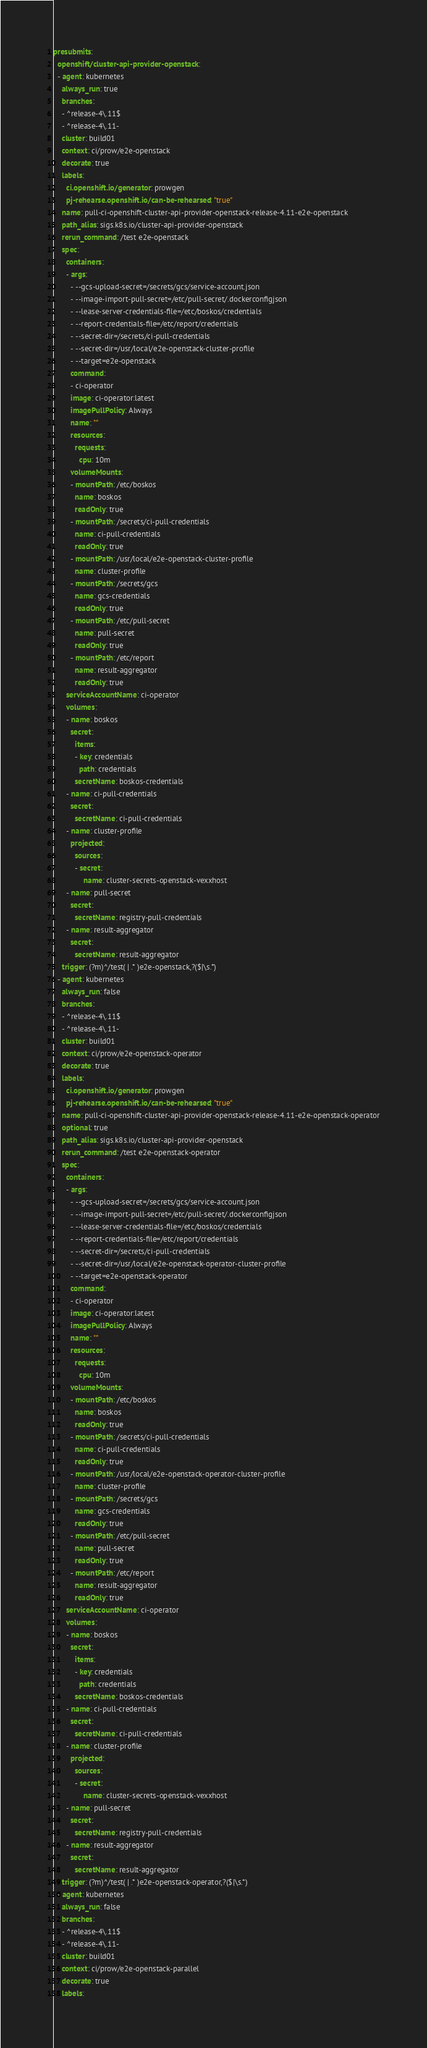Convert code to text. <code><loc_0><loc_0><loc_500><loc_500><_YAML_>presubmits:
  openshift/cluster-api-provider-openstack:
  - agent: kubernetes
    always_run: true
    branches:
    - ^release-4\.11$
    - ^release-4\.11-
    cluster: build01
    context: ci/prow/e2e-openstack
    decorate: true
    labels:
      ci.openshift.io/generator: prowgen
      pj-rehearse.openshift.io/can-be-rehearsed: "true"
    name: pull-ci-openshift-cluster-api-provider-openstack-release-4.11-e2e-openstack
    path_alias: sigs.k8s.io/cluster-api-provider-openstack
    rerun_command: /test e2e-openstack
    spec:
      containers:
      - args:
        - --gcs-upload-secret=/secrets/gcs/service-account.json
        - --image-import-pull-secret=/etc/pull-secret/.dockerconfigjson
        - --lease-server-credentials-file=/etc/boskos/credentials
        - --report-credentials-file=/etc/report/credentials
        - --secret-dir=/secrets/ci-pull-credentials
        - --secret-dir=/usr/local/e2e-openstack-cluster-profile
        - --target=e2e-openstack
        command:
        - ci-operator
        image: ci-operator:latest
        imagePullPolicy: Always
        name: ""
        resources:
          requests:
            cpu: 10m
        volumeMounts:
        - mountPath: /etc/boskos
          name: boskos
          readOnly: true
        - mountPath: /secrets/ci-pull-credentials
          name: ci-pull-credentials
          readOnly: true
        - mountPath: /usr/local/e2e-openstack-cluster-profile
          name: cluster-profile
        - mountPath: /secrets/gcs
          name: gcs-credentials
          readOnly: true
        - mountPath: /etc/pull-secret
          name: pull-secret
          readOnly: true
        - mountPath: /etc/report
          name: result-aggregator
          readOnly: true
      serviceAccountName: ci-operator
      volumes:
      - name: boskos
        secret:
          items:
          - key: credentials
            path: credentials
          secretName: boskos-credentials
      - name: ci-pull-credentials
        secret:
          secretName: ci-pull-credentials
      - name: cluster-profile
        projected:
          sources:
          - secret:
              name: cluster-secrets-openstack-vexxhost
      - name: pull-secret
        secret:
          secretName: registry-pull-credentials
      - name: result-aggregator
        secret:
          secretName: result-aggregator
    trigger: (?m)^/test( | .* )e2e-openstack,?($|\s.*)
  - agent: kubernetes
    always_run: false
    branches:
    - ^release-4\.11$
    - ^release-4\.11-
    cluster: build01
    context: ci/prow/e2e-openstack-operator
    decorate: true
    labels:
      ci.openshift.io/generator: prowgen
      pj-rehearse.openshift.io/can-be-rehearsed: "true"
    name: pull-ci-openshift-cluster-api-provider-openstack-release-4.11-e2e-openstack-operator
    optional: true
    path_alias: sigs.k8s.io/cluster-api-provider-openstack
    rerun_command: /test e2e-openstack-operator
    spec:
      containers:
      - args:
        - --gcs-upload-secret=/secrets/gcs/service-account.json
        - --image-import-pull-secret=/etc/pull-secret/.dockerconfigjson
        - --lease-server-credentials-file=/etc/boskos/credentials
        - --report-credentials-file=/etc/report/credentials
        - --secret-dir=/secrets/ci-pull-credentials
        - --secret-dir=/usr/local/e2e-openstack-operator-cluster-profile
        - --target=e2e-openstack-operator
        command:
        - ci-operator
        image: ci-operator:latest
        imagePullPolicy: Always
        name: ""
        resources:
          requests:
            cpu: 10m
        volumeMounts:
        - mountPath: /etc/boskos
          name: boskos
          readOnly: true
        - mountPath: /secrets/ci-pull-credentials
          name: ci-pull-credentials
          readOnly: true
        - mountPath: /usr/local/e2e-openstack-operator-cluster-profile
          name: cluster-profile
        - mountPath: /secrets/gcs
          name: gcs-credentials
          readOnly: true
        - mountPath: /etc/pull-secret
          name: pull-secret
          readOnly: true
        - mountPath: /etc/report
          name: result-aggregator
          readOnly: true
      serviceAccountName: ci-operator
      volumes:
      - name: boskos
        secret:
          items:
          - key: credentials
            path: credentials
          secretName: boskos-credentials
      - name: ci-pull-credentials
        secret:
          secretName: ci-pull-credentials
      - name: cluster-profile
        projected:
          sources:
          - secret:
              name: cluster-secrets-openstack-vexxhost
      - name: pull-secret
        secret:
          secretName: registry-pull-credentials
      - name: result-aggregator
        secret:
          secretName: result-aggregator
    trigger: (?m)^/test( | .* )e2e-openstack-operator,?($|\s.*)
  - agent: kubernetes
    always_run: false
    branches:
    - ^release-4\.11$
    - ^release-4\.11-
    cluster: build01
    context: ci/prow/e2e-openstack-parallel
    decorate: true
    labels:</code> 